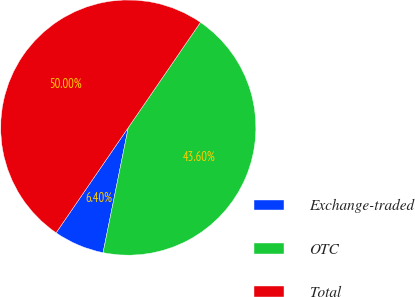<chart> <loc_0><loc_0><loc_500><loc_500><pie_chart><fcel>Exchange-traded<fcel>OTC<fcel>Total<nl><fcel>6.4%<fcel>43.6%<fcel>50.0%<nl></chart> 